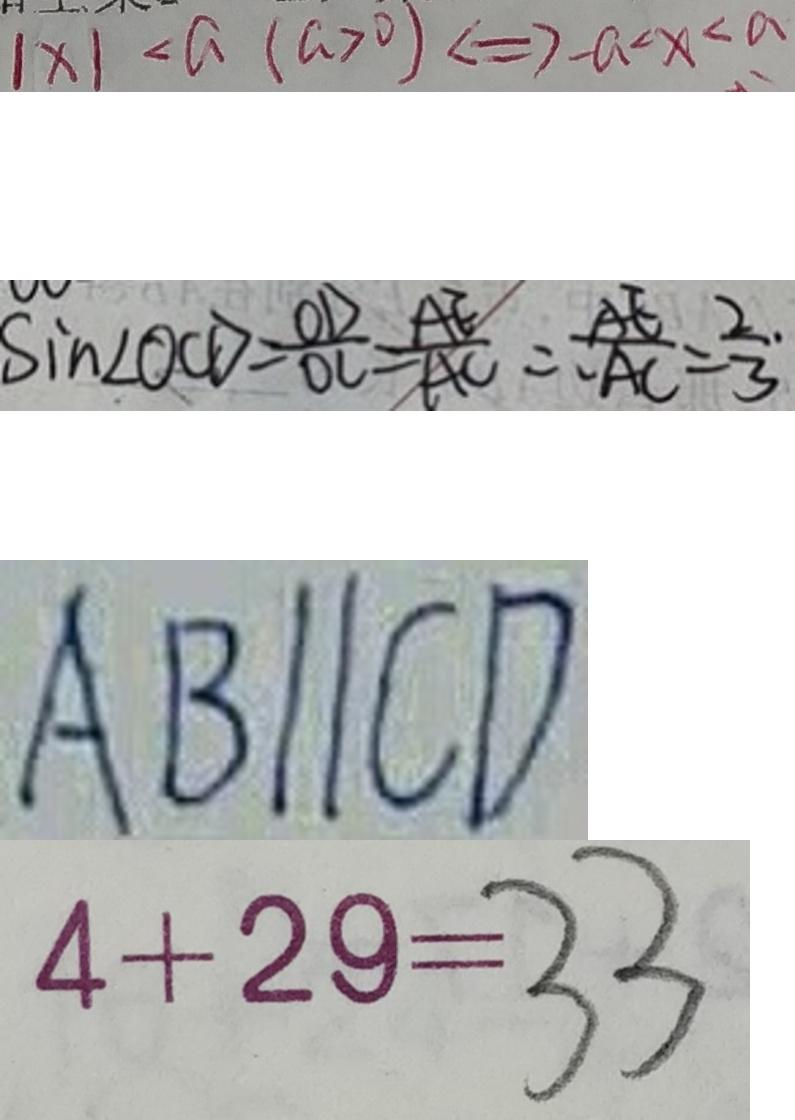Convert formula to latex. <formula><loc_0><loc_0><loc_500><loc_500>\vert x \vert < a ( a > 0 ) \Leftrightarrow - a < x < a 
 \sin \angle O C D = \frac { O D } { O C } = \frac { A E } { A C } \therefore \frac { A E } { A C } = \frac { 2 } { 3 } \cdot 
 A B / / C D 
 4 + 2 9 = 3 3</formula> 